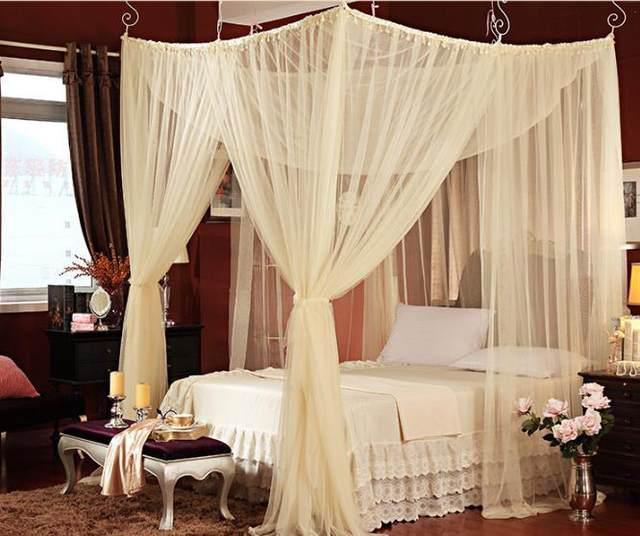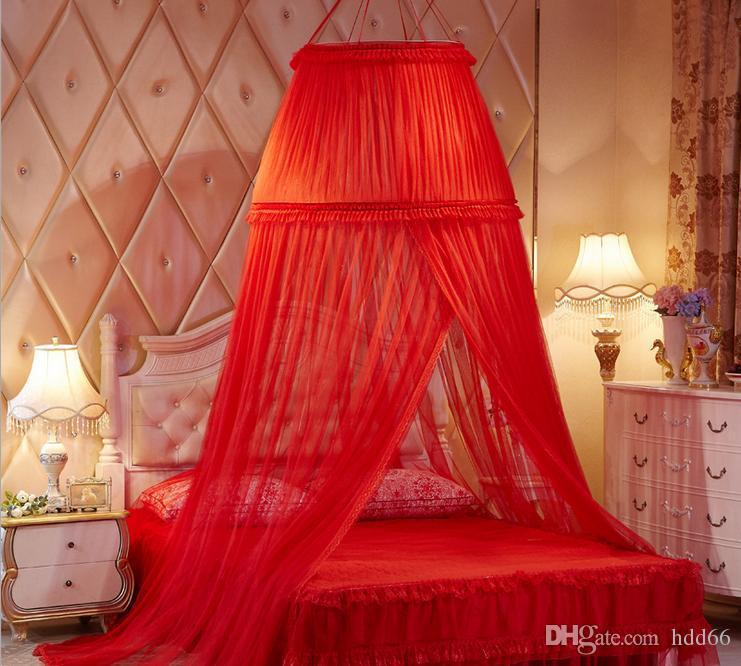The first image is the image on the left, the second image is the image on the right. Given the left and right images, does the statement "The left bed is covered by a square drape, the right bed by a round drape." hold true? Answer yes or no. Yes. The first image is the image on the left, the second image is the image on the right. Analyze the images presented: Is the assertion "All curtains displayed are pink or red and hung from a circular shaped rod directly above the bed." valid? Answer yes or no. No. 